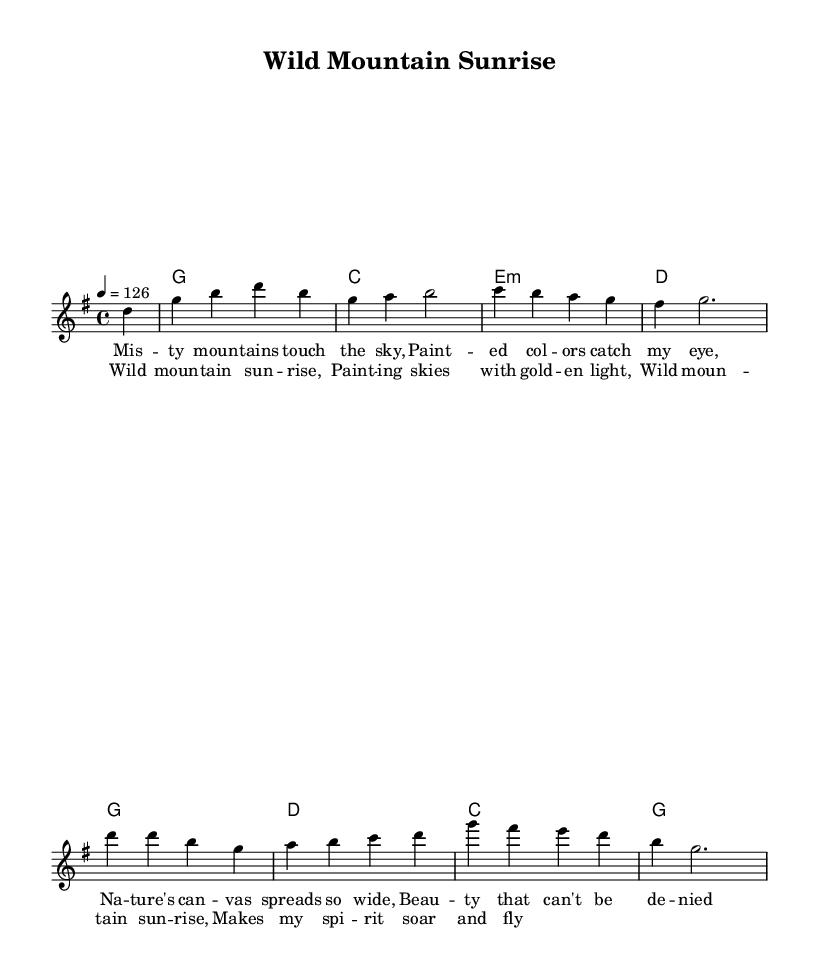What is the key signature of this music? The key signature is G major, which has one sharp, F#. This can be identified by looking at the key signature indication at the beginning of the staff.
Answer: G major What is the time signature of this music? The time signature is 4/4, which means there are four beats in each measure. This is noted at the beginning of the piece, indicated by the "4/4" symbol.
Answer: 4/4 What is the tempo marking for this piece? The tempo marking is "4 = 126," which means that there should be 126 beats per minute at the quarter note. It is found at the beginning of the score as part of the global settings.
Answer: 126 How many measures are in the melody? The melody consists of 8 measures, indicated by the number of vertical bar lines that separate each measure in the music staff.
Answer: 8 What is the mood conveyed by the chorus lyrics? The lyrics of the chorus express joy and awe, suggesting an uplifting and celebratory mood. The phrase "Makes my spirit soar and fly" particularly emphasizes a sense of freedom and exhilaration, characteristic of upbeat country rock anthems.
Answer: Joy Which chord appears most frequently in the harmonies? The G chord appears most frequently in the harmonies, as it is listed multiple times throughout the chord progression. Counting the occurrences of each chord clearly shows that G is the most used.
Answer: G What thematic element do the lyrics focus on? The lyrics focus on the beauty of nature, with specific references to mountains and sunrises, emphasizing scenic landscapes which are common themes in country rock music.
Answer: Nature 